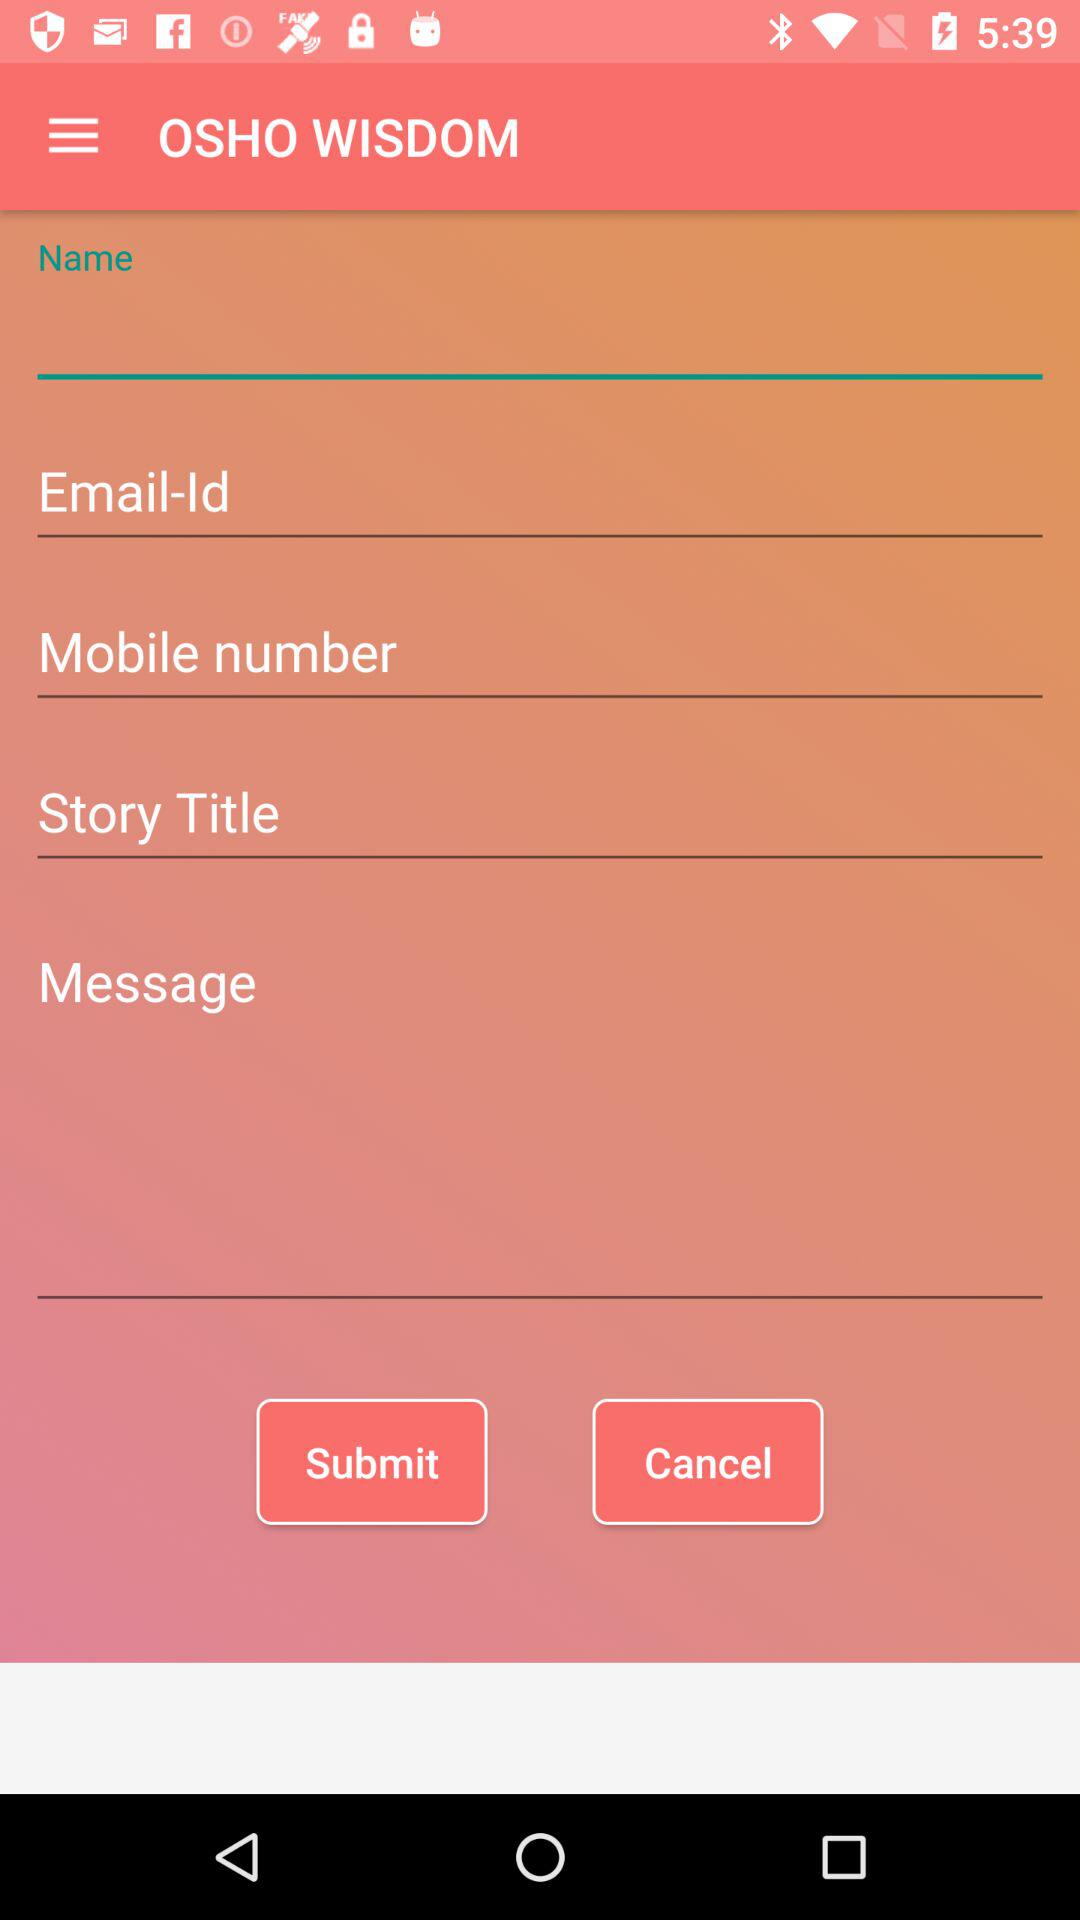What is the name of the application? The name of the application is "OSHO WISDOM". 